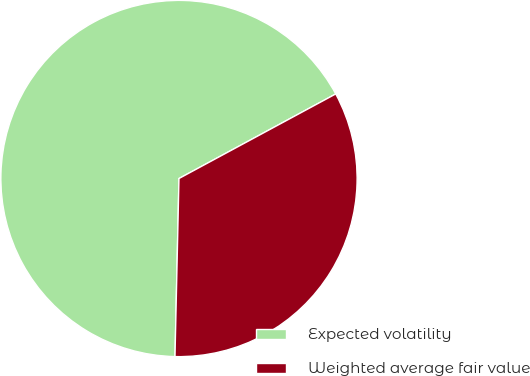Convert chart. <chart><loc_0><loc_0><loc_500><loc_500><pie_chart><fcel>Expected volatility<fcel>Weighted average fair value<nl><fcel>66.77%<fcel>33.23%<nl></chart> 